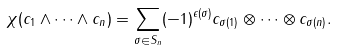Convert formula to latex. <formula><loc_0><loc_0><loc_500><loc_500>\chi ( c _ { 1 } \wedge \cdots \wedge c _ { n } ) = \sum _ { \sigma \in S _ { n } } ( - 1 ) ^ { \epsilon ( \sigma ) } c _ { \sigma ( 1 ) } \otimes \cdots \otimes c _ { \sigma ( n ) } .</formula> 